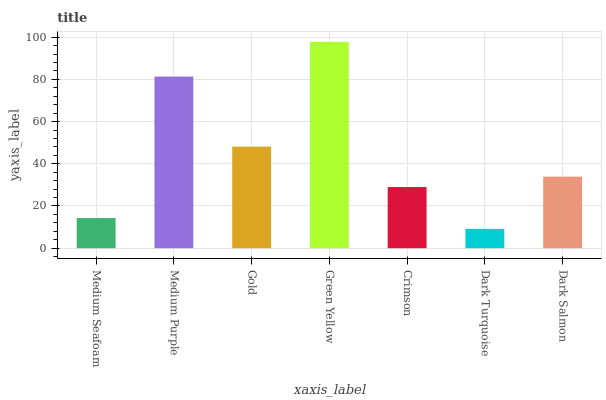Is Dark Turquoise the minimum?
Answer yes or no. Yes. Is Green Yellow the maximum?
Answer yes or no. Yes. Is Medium Purple the minimum?
Answer yes or no. No. Is Medium Purple the maximum?
Answer yes or no. No. Is Medium Purple greater than Medium Seafoam?
Answer yes or no. Yes. Is Medium Seafoam less than Medium Purple?
Answer yes or no. Yes. Is Medium Seafoam greater than Medium Purple?
Answer yes or no. No. Is Medium Purple less than Medium Seafoam?
Answer yes or no. No. Is Dark Salmon the high median?
Answer yes or no. Yes. Is Dark Salmon the low median?
Answer yes or no. Yes. Is Medium Purple the high median?
Answer yes or no. No. Is Medium Purple the low median?
Answer yes or no. No. 